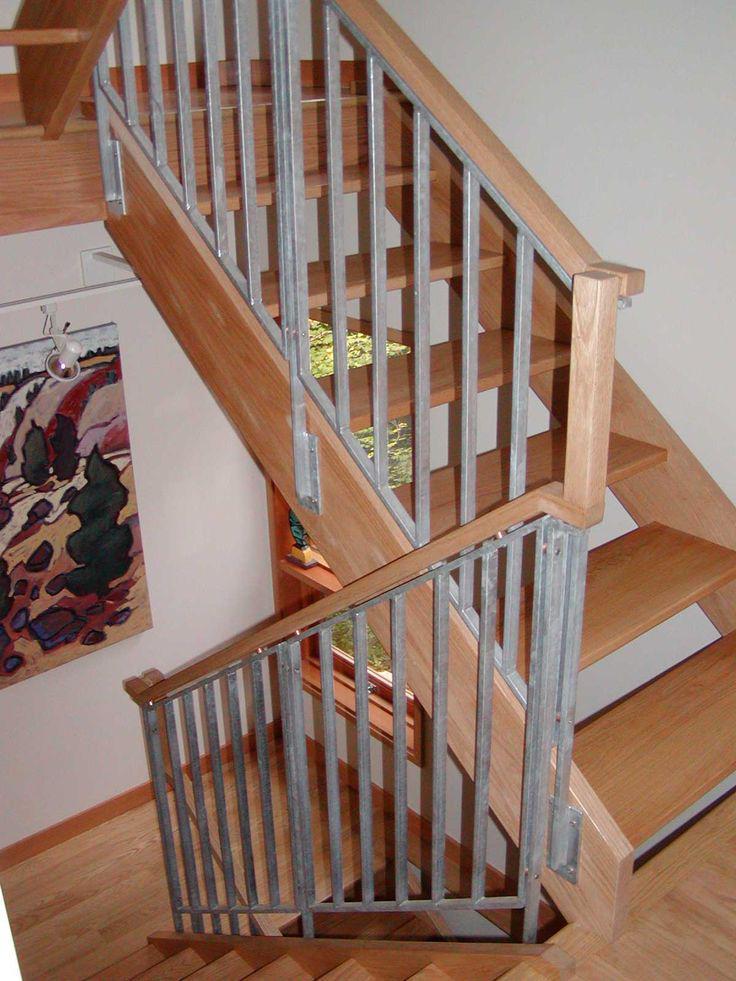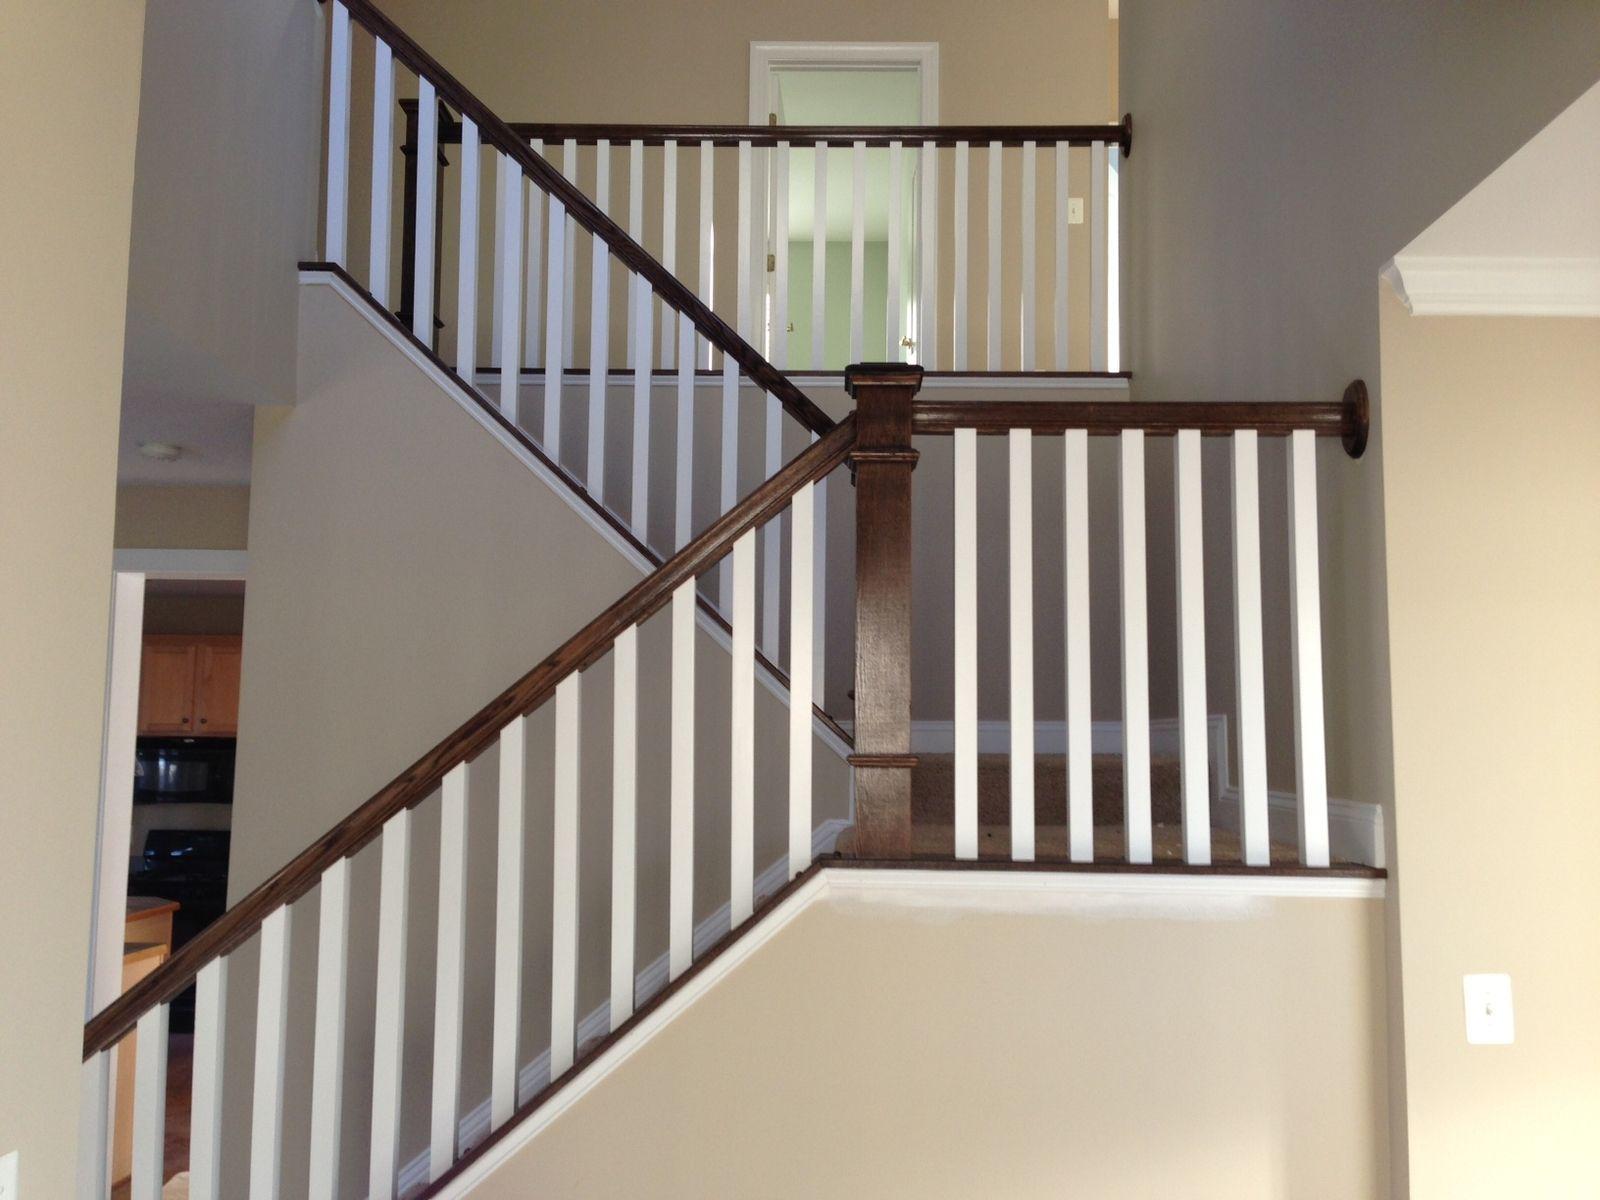The first image is the image on the left, the second image is the image on the right. Considering the images on both sides, is "One stair railing is brown and the other is black." valid? Answer yes or no. No. The first image is the image on the left, the second image is the image on the right. Considering the images on both sides, is "In at least one image there are white stair covered with brown wood top next to a black metal ball railing." valid? Answer yes or no. No. 